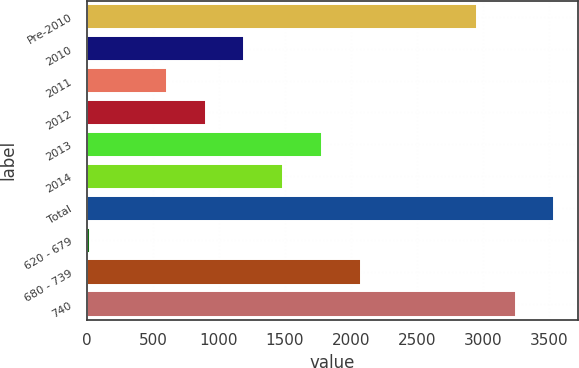<chart> <loc_0><loc_0><loc_500><loc_500><bar_chart><fcel>Pre-2010<fcel>2010<fcel>2011<fcel>2012<fcel>2013<fcel>2014<fcel>Total<fcel>620 - 679<fcel>680 - 739<fcel>740<nl><fcel>2955<fcel>1192.8<fcel>605.4<fcel>899.1<fcel>1780.2<fcel>1486.5<fcel>3542.4<fcel>18<fcel>2073.9<fcel>3248.7<nl></chart> 